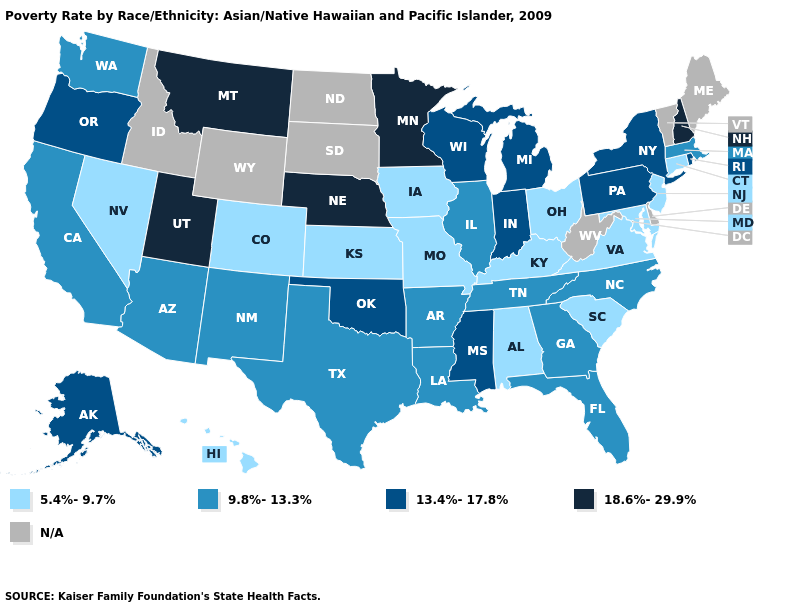Does Indiana have the highest value in the MidWest?
Write a very short answer. No. Which states hav the highest value in the West?
Quick response, please. Montana, Utah. Name the states that have a value in the range 5.4%-9.7%?
Keep it brief. Alabama, Colorado, Connecticut, Hawaii, Iowa, Kansas, Kentucky, Maryland, Missouri, Nevada, New Jersey, Ohio, South Carolina, Virginia. What is the value of New Mexico?
Answer briefly. 9.8%-13.3%. Among the states that border Arizona , does California have the highest value?
Quick response, please. No. Does the first symbol in the legend represent the smallest category?
Quick response, please. Yes. What is the highest value in states that border Louisiana?
Keep it brief. 13.4%-17.8%. Among the states that border Missouri , which have the highest value?
Give a very brief answer. Nebraska. What is the value of Virginia?
Short answer required. 5.4%-9.7%. What is the value of Florida?
Short answer required. 9.8%-13.3%. Which states have the lowest value in the USA?
Keep it brief. Alabama, Colorado, Connecticut, Hawaii, Iowa, Kansas, Kentucky, Maryland, Missouri, Nevada, New Jersey, Ohio, South Carolina, Virginia. What is the lowest value in the West?
Keep it brief. 5.4%-9.7%. How many symbols are there in the legend?
Concise answer only. 5. Name the states that have a value in the range 18.6%-29.9%?
Concise answer only. Minnesota, Montana, Nebraska, New Hampshire, Utah. 